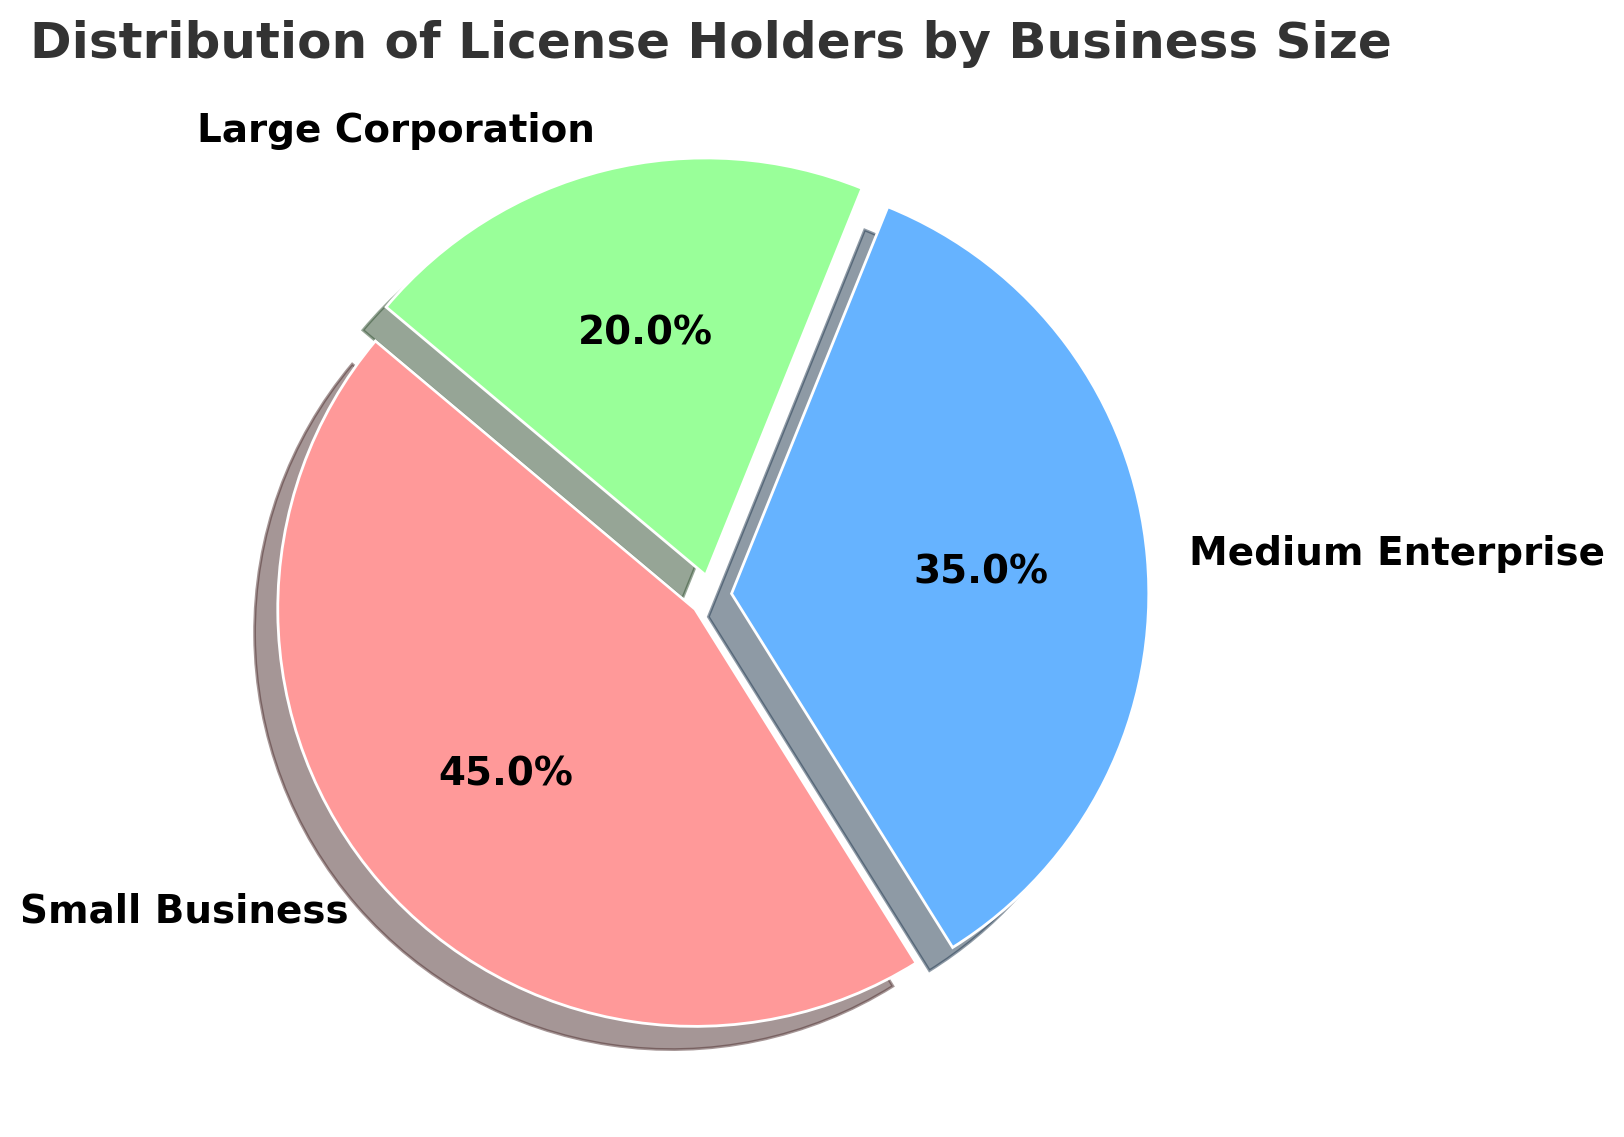What is the percentage of small businesses holding licenses? The figure shows the proportion of different business sizes holding licenses. The small business segment is marked in the legend. The corresponding slice of the pie chart indicates the percentage is 45%.
Answer: 45% How many more percentage points do medium enterprises have compared to large corporations? From the pie chart, medium enterprises hold 35% and large corporations hold 20%. The difference is calculated as 35% - 20% = 15%.
Answer: 15% Which business size holds the largest share of licenses? Observing the pie chart, the largest segment belongs to the small businesses, which is the largest share at 45%.
Answer: Small Business What percentage of licenses is held by medium enterprises and large corporations combined? Medium enterprises hold 35% and large corporations hold 20%. Summing these gives 35% + 20% = 55%.
Answer: 55% Is there any business size that holds less than a quarter of total licenses? The pie chart shows that large corporations hold 20% of the licenses, which is less than 25% (a quarter).
Answer: Yes What is the difference in percentage points between the small business and the medium enterprise segments? The pie chart indicates that small businesses hold 45% of the licenses and medium enterprises hold 35%. The difference is 45% - 35% = 10%.
Answer: 10% What is the combined percentage of licenses held by non-small businesses? Non-small businesses are medium enterprises and large corporations. Adding their percentages: 35% + 20% = 55%.
Answer: 55% What colors are used to represent small businesses, medium enterprises, and large corporations in the pie chart? The pie chart uses red for small businesses, blue for medium enterprises, and green for large corporations.
Answer: red, blue, green Which two business segments combined represent less than half of the total licenses? The two smallest segments are medium enterprises and large corporations. Adding their shares gives 35% + 20% = 55%, not less than half. The two other combinations are small business and large corporation (45% + 20%) and small business and medium enterprise (45% + 35%), both exceeding 50%. Thus, there is no such combination.
Answer: None Are the wedges in the pie chart separated to improve visualization? Each wedge in the pie chart is slightly exploded, showing a small separation between them to improve visualization.
Answer: Yes 